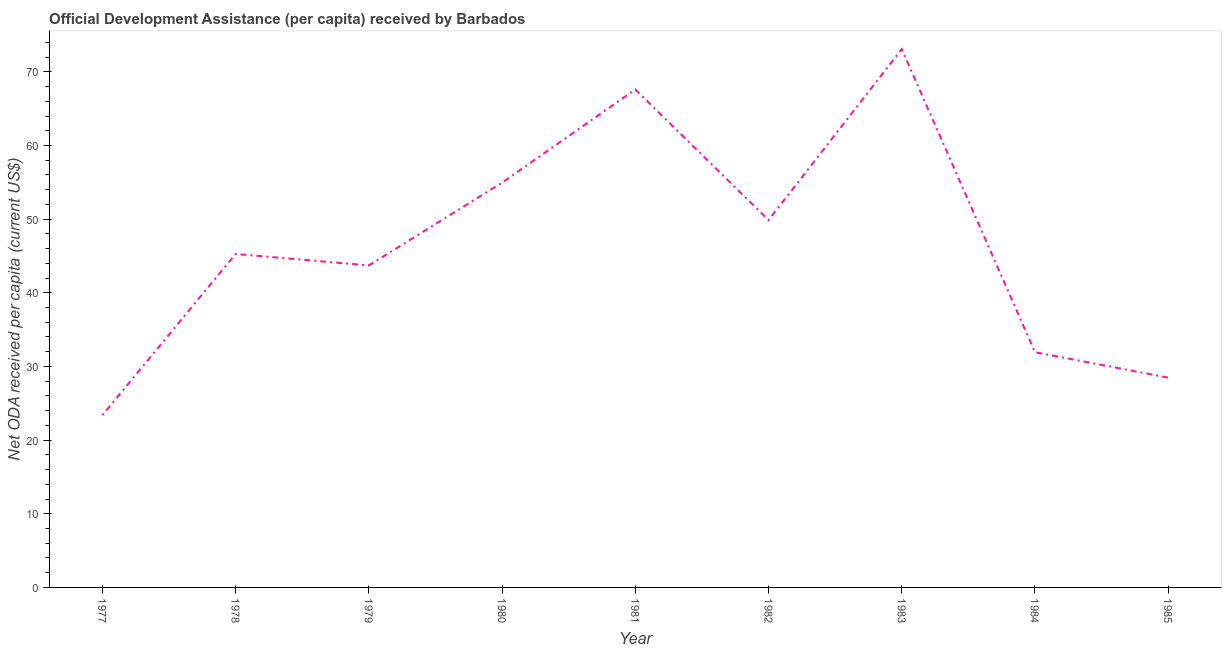What is the net oda received per capita in 1984?
Give a very brief answer. 31.94. Across all years, what is the maximum net oda received per capita?
Offer a terse response. 73.08. Across all years, what is the minimum net oda received per capita?
Offer a terse response. 23.39. In which year was the net oda received per capita maximum?
Your answer should be compact. 1983. What is the sum of the net oda received per capita?
Provide a succinct answer. 418.32. What is the difference between the net oda received per capita in 1982 and 1983?
Provide a short and direct response. -23.21. What is the average net oda received per capita per year?
Ensure brevity in your answer.  46.48. What is the median net oda received per capita?
Provide a succinct answer. 45.27. In how many years, is the net oda received per capita greater than 16 US$?
Make the answer very short. 9. What is the ratio of the net oda received per capita in 1983 to that in 1984?
Your answer should be compact. 2.29. Is the difference between the net oda received per capita in 1977 and 1979 greater than the difference between any two years?
Give a very brief answer. No. What is the difference between the highest and the second highest net oda received per capita?
Ensure brevity in your answer.  5.47. Is the sum of the net oda received per capita in 1979 and 1982 greater than the maximum net oda received per capita across all years?
Ensure brevity in your answer.  Yes. What is the difference between the highest and the lowest net oda received per capita?
Make the answer very short. 49.69. In how many years, is the net oda received per capita greater than the average net oda received per capita taken over all years?
Keep it short and to the point. 4. Does the net oda received per capita monotonically increase over the years?
Offer a very short reply. No. How many lines are there?
Your answer should be compact. 1. What is the difference between two consecutive major ticks on the Y-axis?
Give a very brief answer. 10. Does the graph contain any zero values?
Offer a very short reply. No. Does the graph contain grids?
Offer a very short reply. No. What is the title of the graph?
Provide a short and direct response. Official Development Assistance (per capita) received by Barbados. What is the label or title of the X-axis?
Your answer should be compact. Year. What is the label or title of the Y-axis?
Make the answer very short. Net ODA received per capita (current US$). What is the Net ODA received per capita (current US$) of 1977?
Your answer should be very brief. 23.39. What is the Net ODA received per capita (current US$) of 1978?
Ensure brevity in your answer.  45.27. What is the Net ODA received per capita (current US$) of 1979?
Your response must be concise. 43.71. What is the Net ODA received per capita (current US$) in 1980?
Ensure brevity in your answer.  54.96. What is the Net ODA received per capita (current US$) in 1981?
Provide a short and direct response. 67.61. What is the Net ODA received per capita (current US$) of 1982?
Provide a short and direct response. 49.87. What is the Net ODA received per capita (current US$) of 1983?
Your answer should be very brief. 73.08. What is the Net ODA received per capita (current US$) in 1984?
Your answer should be very brief. 31.94. What is the Net ODA received per capita (current US$) in 1985?
Your answer should be very brief. 28.48. What is the difference between the Net ODA received per capita (current US$) in 1977 and 1978?
Keep it short and to the point. -21.88. What is the difference between the Net ODA received per capita (current US$) in 1977 and 1979?
Give a very brief answer. -20.32. What is the difference between the Net ODA received per capita (current US$) in 1977 and 1980?
Provide a short and direct response. -31.56. What is the difference between the Net ODA received per capita (current US$) in 1977 and 1981?
Provide a succinct answer. -44.21. What is the difference between the Net ODA received per capita (current US$) in 1977 and 1982?
Provide a short and direct response. -26.48. What is the difference between the Net ODA received per capita (current US$) in 1977 and 1983?
Provide a succinct answer. -49.69. What is the difference between the Net ODA received per capita (current US$) in 1977 and 1984?
Give a very brief answer. -8.54. What is the difference between the Net ODA received per capita (current US$) in 1977 and 1985?
Provide a short and direct response. -5.09. What is the difference between the Net ODA received per capita (current US$) in 1978 and 1979?
Offer a terse response. 1.56. What is the difference between the Net ODA received per capita (current US$) in 1978 and 1980?
Make the answer very short. -9.68. What is the difference between the Net ODA received per capita (current US$) in 1978 and 1981?
Provide a short and direct response. -22.33. What is the difference between the Net ODA received per capita (current US$) in 1978 and 1982?
Keep it short and to the point. -4.6. What is the difference between the Net ODA received per capita (current US$) in 1978 and 1983?
Offer a terse response. -27.81. What is the difference between the Net ODA received per capita (current US$) in 1978 and 1984?
Ensure brevity in your answer.  13.34. What is the difference between the Net ODA received per capita (current US$) in 1978 and 1985?
Your response must be concise. 16.79. What is the difference between the Net ODA received per capita (current US$) in 1979 and 1980?
Offer a terse response. -11.24. What is the difference between the Net ODA received per capita (current US$) in 1979 and 1981?
Provide a short and direct response. -23.89. What is the difference between the Net ODA received per capita (current US$) in 1979 and 1982?
Keep it short and to the point. -6.16. What is the difference between the Net ODA received per capita (current US$) in 1979 and 1983?
Offer a very short reply. -29.37. What is the difference between the Net ODA received per capita (current US$) in 1979 and 1984?
Make the answer very short. 11.78. What is the difference between the Net ODA received per capita (current US$) in 1979 and 1985?
Offer a very short reply. 15.23. What is the difference between the Net ODA received per capita (current US$) in 1980 and 1981?
Your answer should be very brief. -12.65. What is the difference between the Net ODA received per capita (current US$) in 1980 and 1982?
Provide a short and direct response. 5.08. What is the difference between the Net ODA received per capita (current US$) in 1980 and 1983?
Offer a very short reply. -18.12. What is the difference between the Net ODA received per capita (current US$) in 1980 and 1984?
Offer a terse response. 23.02. What is the difference between the Net ODA received per capita (current US$) in 1980 and 1985?
Your answer should be very brief. 26.47. What is the difference between the Net ODA received per capita (current US$) in 1981 and 1982?
Offer a very short reply. 17.73. What is the difference between the Net ODA received per capita (current US$) in 1981 and 1983?
Ensure brevity in your answer.  -5.47. What is the difference between the Net ODA received per capita (current US$) in 1981 and 1984?
Provide a short and direct response. 35.67. What is the difference between the Net ODA received per capita (current US$) in 1981 and 1985?
Provide a succinct answer. 39.12. What is the difference between the Net ODA received per capita (current US$) in 1982 and 1983?
Your answer should be compact. -23.21. What is the difference between the Net ODA received per capita (current US$) in 1982 and 1984?
Your answer should be very brief. 17.94. What is the difference between the Net ODA received per capita (current US$) in 1982 and 1985?
Make the answer very short. 21.39. What is the difference between the Net ODA received per capita (current US$) in 1983 and 1984?
Provide a short and direct response. 41.14. What is the difference between the Net ODA received per capita (current US$) in 1983 and 1985?
Your response must be concise. 44.6. What is the difference between the Net ODA received per capita (current US$) in 1984 and 1985?
Make the answer very short. 3.45. What is the ratio of the Net ODA received per capita (current US$) in 1977 to that in 1978?
Your response must be concise. 0.52. What is the ratio of the Net ODA received per capita (current US$) in 1977 to that in 1979?
Your answer should be very brief. 0.54. What is the ratio of the Net ODA received per capita (current US$) in 1977 to that in 1980?
Your answer should be compact. 0.43. What is the ratio of the Net ODA received per capita (current US$) in 1977 to that in 1981?
Ensure brevity in your answer.  0.35. What is the ratio of the Net ODA received per capita (current US$) in 1977 to that in 1982?
Keep it short and to the point. 0.47. What is the ratio of the Net ODA received per capita (current US$) in 1977 to that in 1983?
Offer a terse response. 0.32. What is the ratio of the Net ODA received per capita (current US$) in 1977 to that in 1984?
Provide a short and direct response. 0.73. What is the ratio of the Net ODA received per capita (current US$) in 1977 to that in 1985?
Keep it short and to the point. 0.82. What is the ratio of the Net ODA received per capita (current US$) in 1978 to that in 1979?
Ensure brevity in your answer.  1.04. What is the ratio of the Net ODA received per capita (current US$) in 1978 to that in 1980?
Keep it short and to the point. 0.82. What is the ratio of the Net ODA received per capita (current US$) in 1978 to that in 1981?
Make the answer very short. 0.67. What is the ratio of the Net ODA received per capita (current US$) in 1978 to that in 1982?
Your answer should be compact. 0.91. What is the ratio of the Net ODA received per capita (current US$) in 1978 to that in 1983?
Provide a succinct answer. 0.62. What is the ratio of the Net ODA received per capita (current US$) in 1978 to that in 1984?
Ensure brevity in your answer.  1.42. What is the ratio of the Net ODA received per capita (current US$) in 1978 to that in 1985?
Your answer should be compact. 1.59. What is the ratio of the Net ODA received per capita (current US$) in 1979 to that in 1980?
Provide a succinct answer. 0.8. What is the ratio of the Net ODA received per capita (current US$) in 1979 to that in 1981?
Your response must be concise. 0.65. What is the ratio of the Net ODA received per capita (current US$) in 1979 to that in 1982?
Keep it short and to the point. 0.88. What is the ratio of the Net ODA received per capita (current US$) in 1979 to that in 1983?
Provide a short and direct response. 0.6. What is the ratio of the Net ODA received per capita (current US$) in 1979 to that in 1984?
Make the answer very short. 1.37. What is the ratio of the Net ODA received per capita (current US$) in 1979 to that in 1985?
Offer a very short reply. 1.53. What is the ratio of the Net ODA received per capita (current US$) in 1980 to that in 1981?
Ensure brevity in your answer.  0.81. What is the ratio of the Net ODA received per capita (current US$) in 1980 to that in 1982?
Keep it short and to the point. 1.1. What is the ratio of the Net ODA received per capita (current US$) in 1980 to that in 1983?
Your answer should be compact. 0.75. What is the ratio of the Net ODA received per capita (current US$) in 1980 to that in 1984?
Provide a short and direct response. 1.72. What is the ratio of the Net ODA received per capita (current US$) in 1980 to that in 1985?
Your answer should be very brief. 1.93. What is the ratio of the Net ODA received per capita (current US$) in 1981 to that in 1982?
Ensure brevity in your answer.  1.36. What is the ratio of the Net ODA received per capita (current US$) in 1981 to that in 1983?
Keep it short and to the point. 0.93. What is the ratio of the Net ODA received per capita (current US$) in 1981 to that in 1984?
Give a very brief answer. 2.12. What is the ratio of the Net ODA received per capita (current US$) in 1981 to that in 1985?
Provide a short and direct response. 2.37. What is the ratio of the Net ODA received per capita (current US$) in 1982 to that in 1983?
Your response must be concise. 0.68. What is the ratio of the Net ODA received per capita (current US$) in 1982 to that in 1984?
Give a very brief answer. 1.56. What is the ratio of the Net ODA received per capita (current US$) in 1982 to that in 1985?
Keep it short and to the point. 1.75. What is the ratio of the Net ODA received per capita (current US$) in 1983 to that in 1984?
Your response must be concise. 2.29. What is the ratio of the Net ODA received per capita (current US$) in 1983 to that in 1985?
Give a very brief answer. 2.57. What is the ratio of the Net ODA received per capita (current US$) in 1984 to that in 1985?
Make the answer very short. 1.12. 